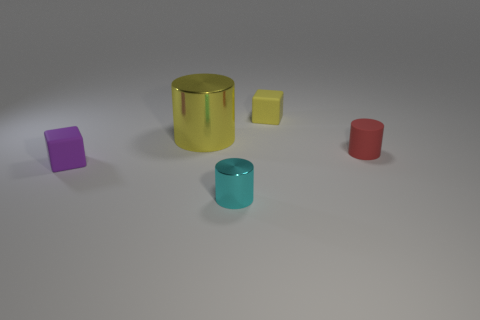Add 2 blue metallic blocks. How many objects exist? 7 Subtract all blocks. How many objects are left? 3 Subtract 0 red cubes. How many objects are left? 5 Subtract all small matte things. Subtract all purple metallic objects. How many objects are left? 2 Add 1 tiny cyan cylinders. How many tiny cyan cylinders are left? 2 Add 5 tiny green metal objects. How many tiny green metal objects exist? 5 